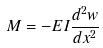<formula> <loc_0><loc_0><loc_500><loc_500>M = - E I \frac { d ^ { 2 } w } { d x ^ { 2 } }</formula> 